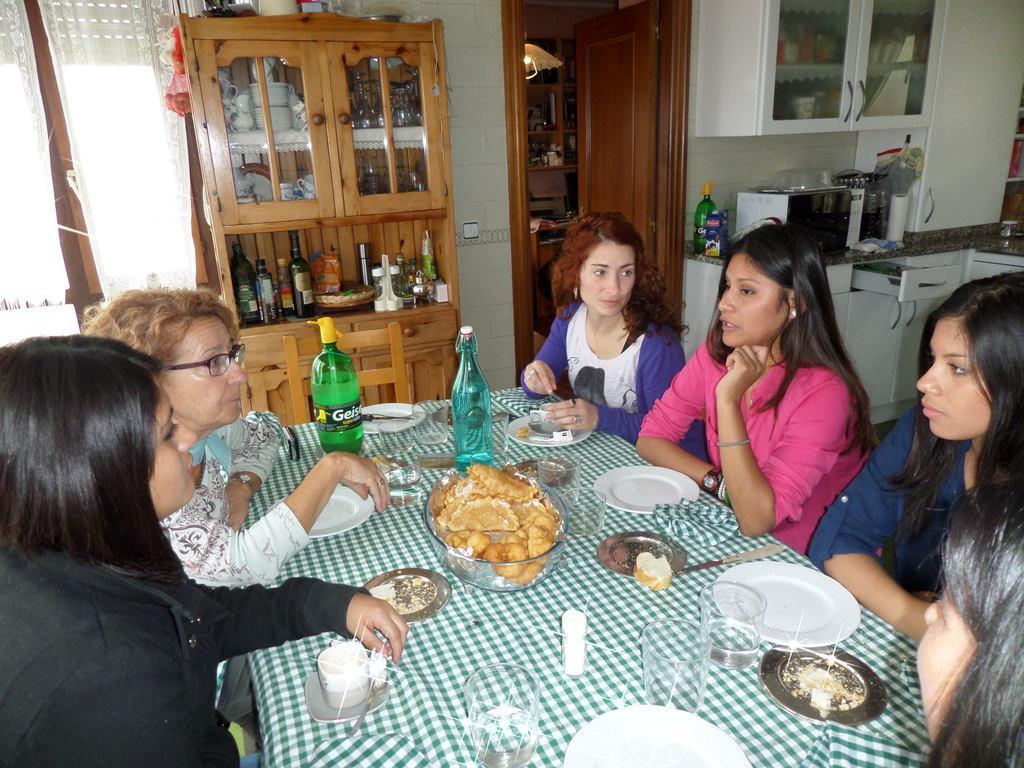Can you describe this image briefly? A group of ladies sitting in a chair and there is a table in front of them which has eatables on it and there is a micro oven behind them. 